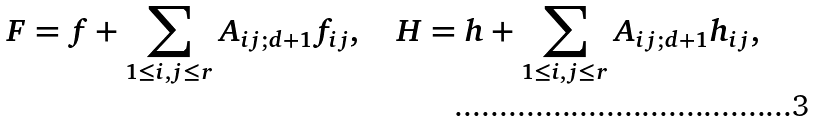<formula> <loc_0><loc_0><loc_500><loc_500>F = f + \sum _ { 1 \leq i , j \leq r } A _ { i j ; d + 1 } f _ { i j } , \quad H = h + \sum _ { 1 \leq i , j \leq r } A _ { i j ; d + 1 } h _ { i j } ,</formula> 